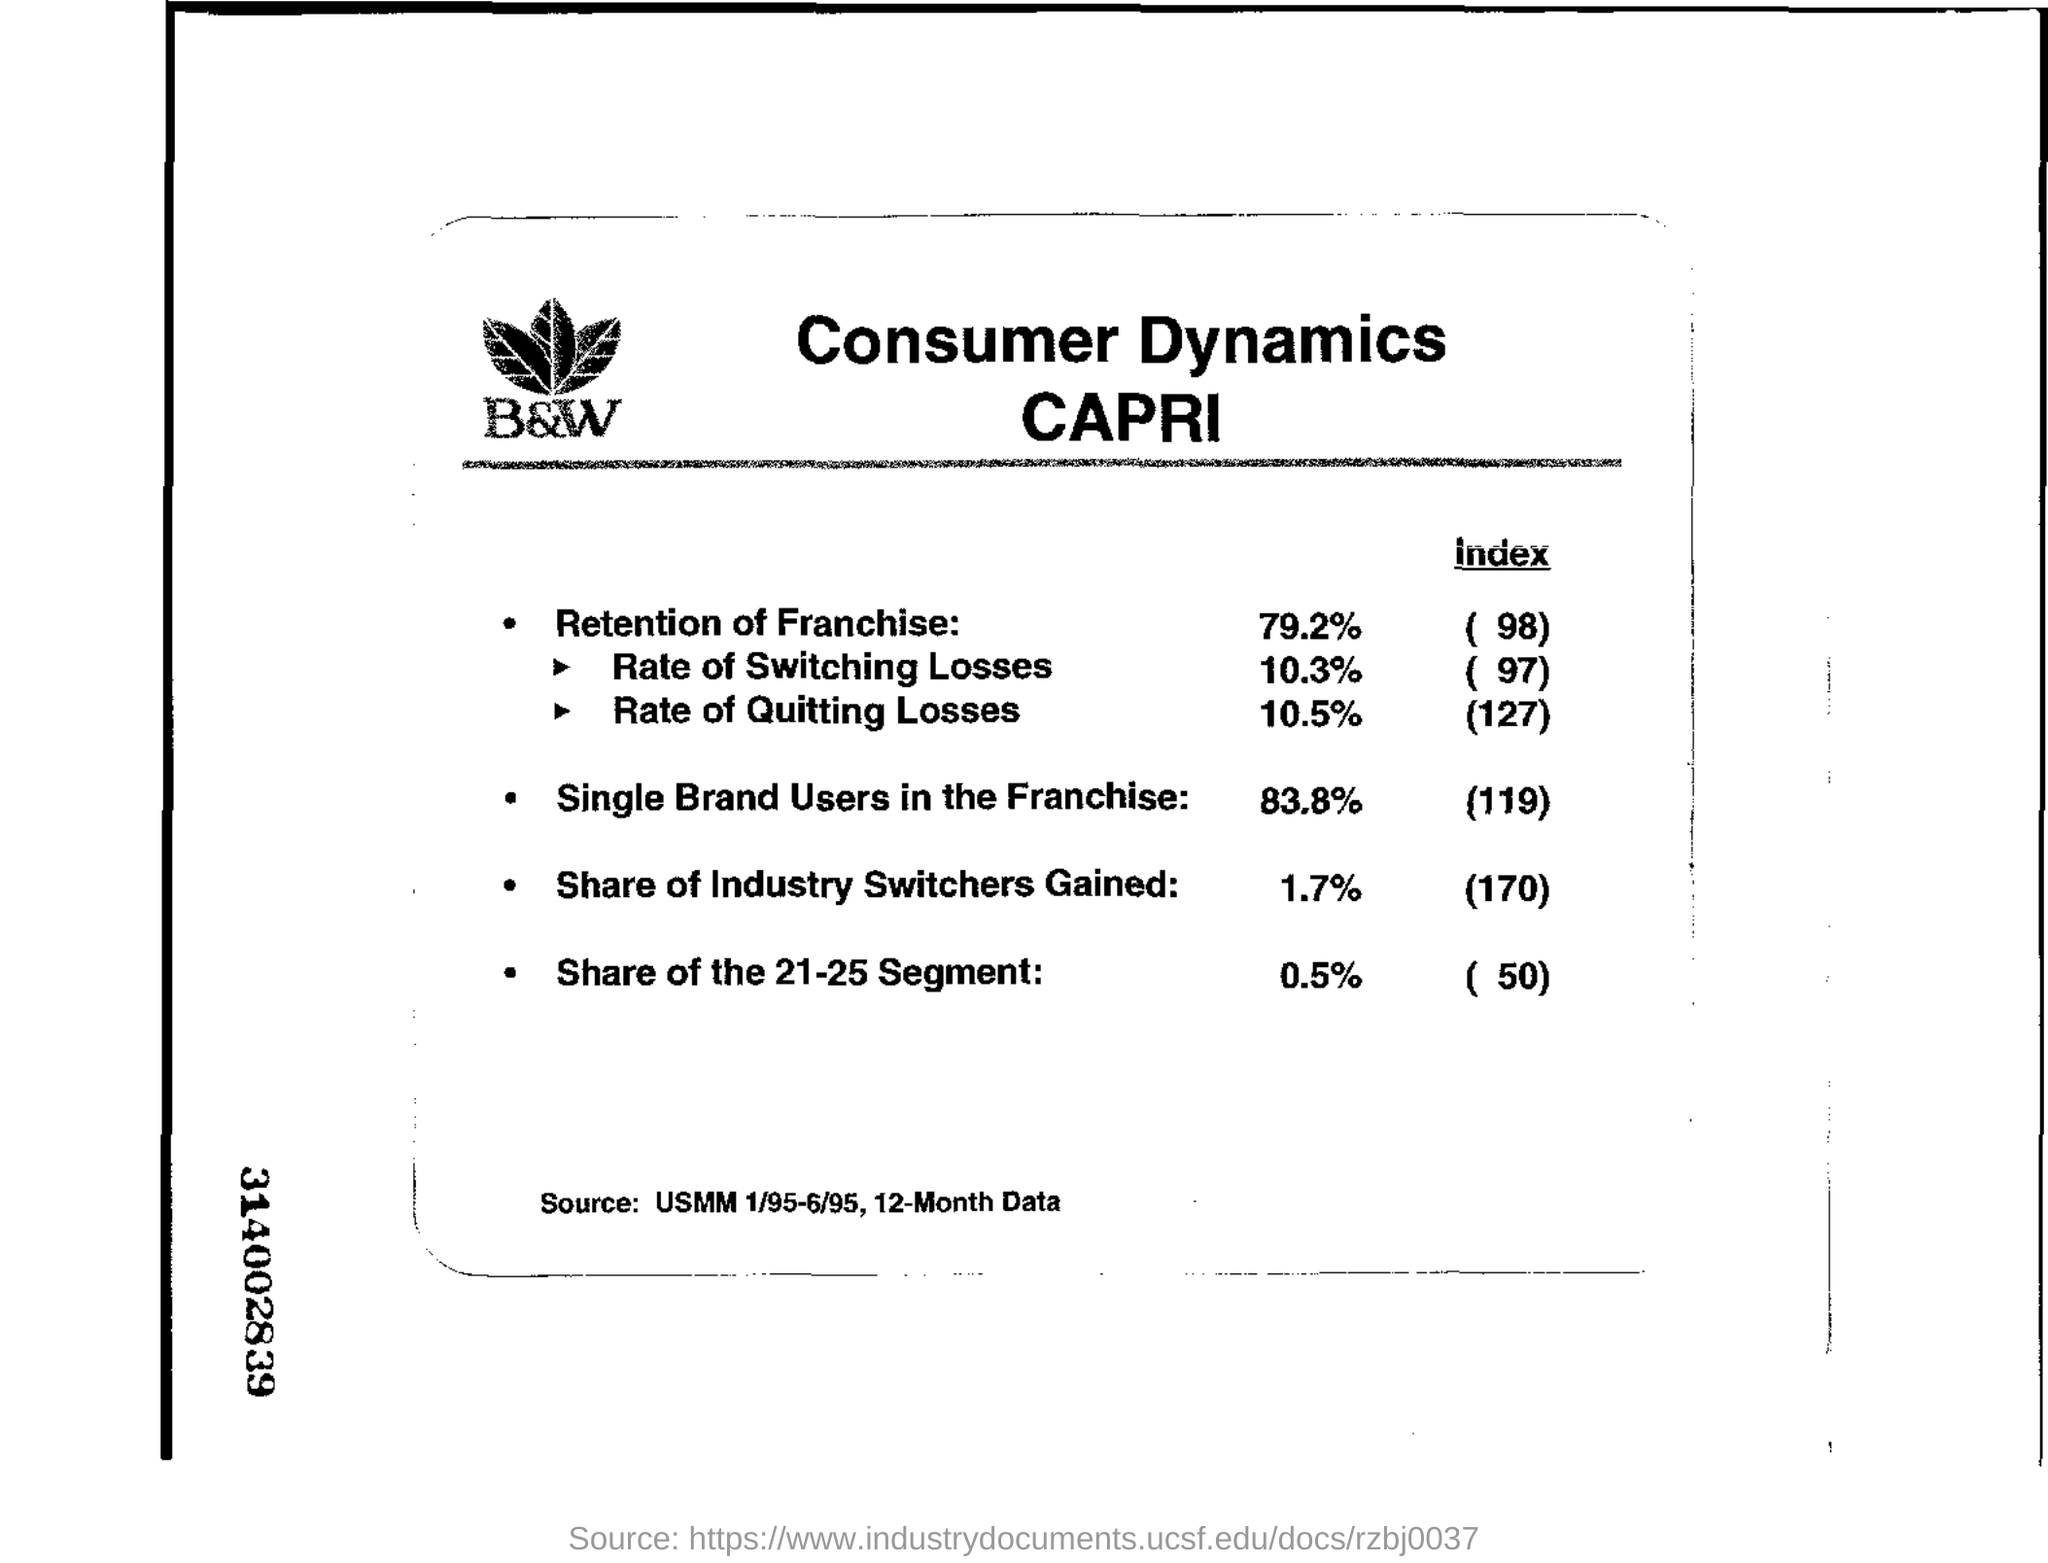List a handful of essential elements in this visual. The retention of franchise is 79.2%. The data has been extracted for a total of 12 months. According to the information provided, the 21-25 segment accounts for 0.5% of the total number of participants in the program. The index of single brand users in the franchise is 119. 